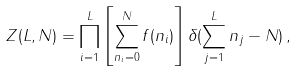Convert formula to latex. <formula><loc_0><loc_0><loc_500><loc_500>Z ( L , N ) = \prod _ { i = 1 } ^ { L } \left [ \sum _ { n _ { i } = 0 } ^ { N } f ( n _ { i } ) \right ] \delta ( \sum _ { j = 1 } ^ { L } n _ { j } - N ) \, ,</formula> 